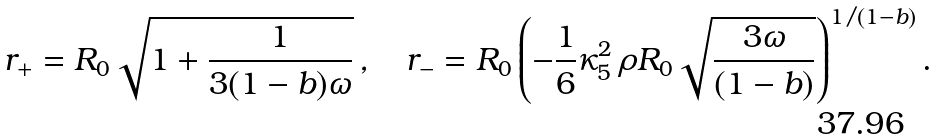<formula> <loc_0><loc_0><loc_500><loc_500>r _ { + } = R _ { 0 } \sqrt { 1 + \frac { 1 } { 3 ( 1 - b ) \omega } } \, , \quad r _ { - } = R _ { 0 } \left ( - \frac { 1 } { 6 } \kappa _ { 5 } ^ { 2 } \, \rho R _ { 0 } \sqrt { \frac { 3 \omega } { ( 1 - b ) } } \right ) ^ { 1 / ( 1 - b ) } .</formula> 